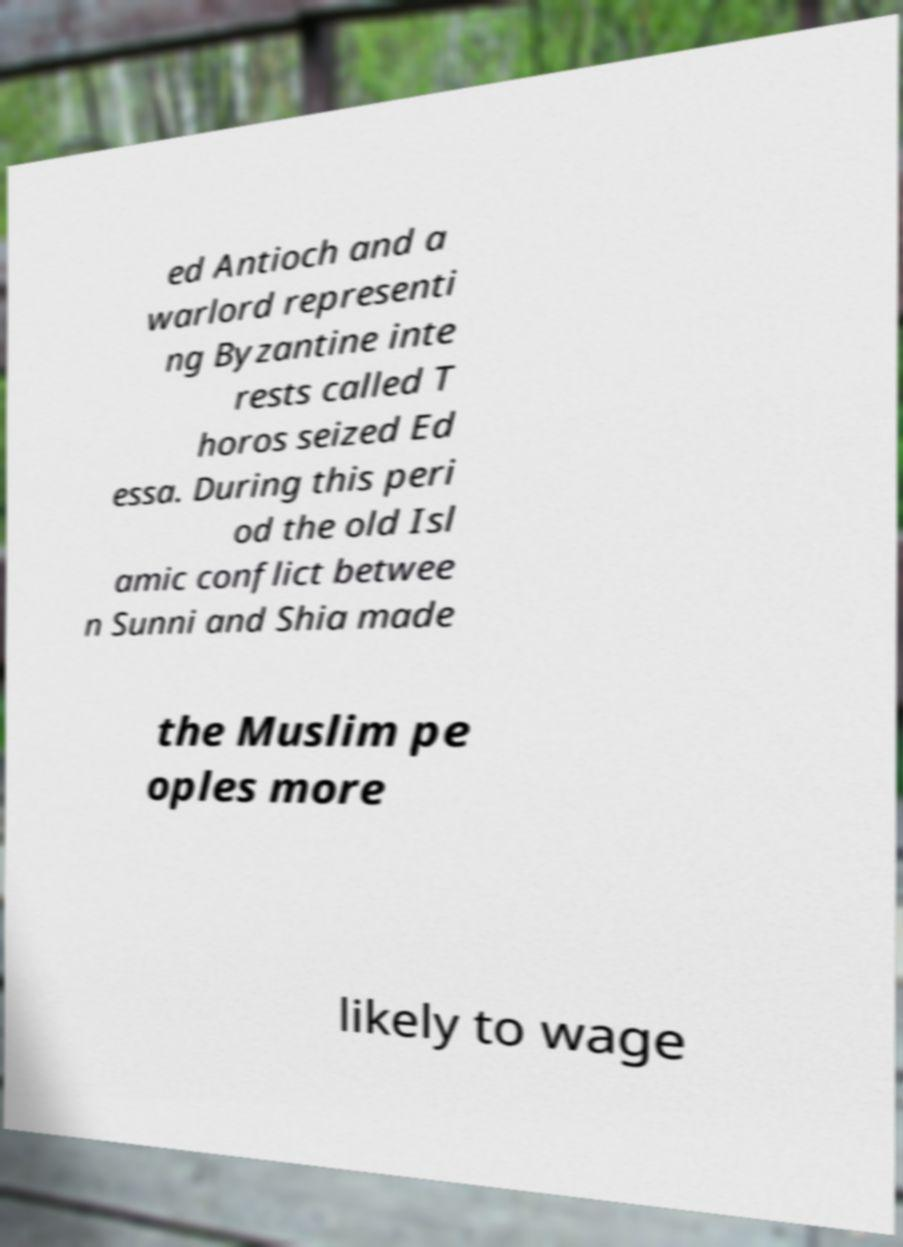Can you read and provide the text displayed in the image?This photo seems to have some interesting text. Can you extract and type it out for me? ed Antioch and a warlord representi ng Byzantine inte rests called T horos seized Ed essa. During this peri od the old Isl amic conflict betwee n Sunni and Shia made the Muslim pe oples more likely to wage 